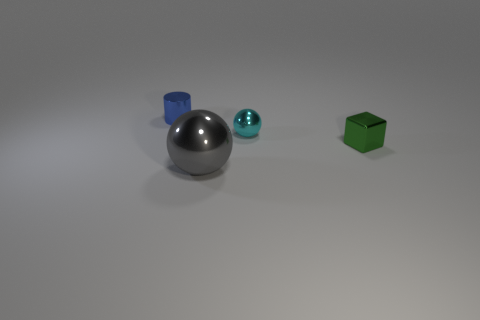What number of other objects are there of the same shape as the cyan metal object? 1 